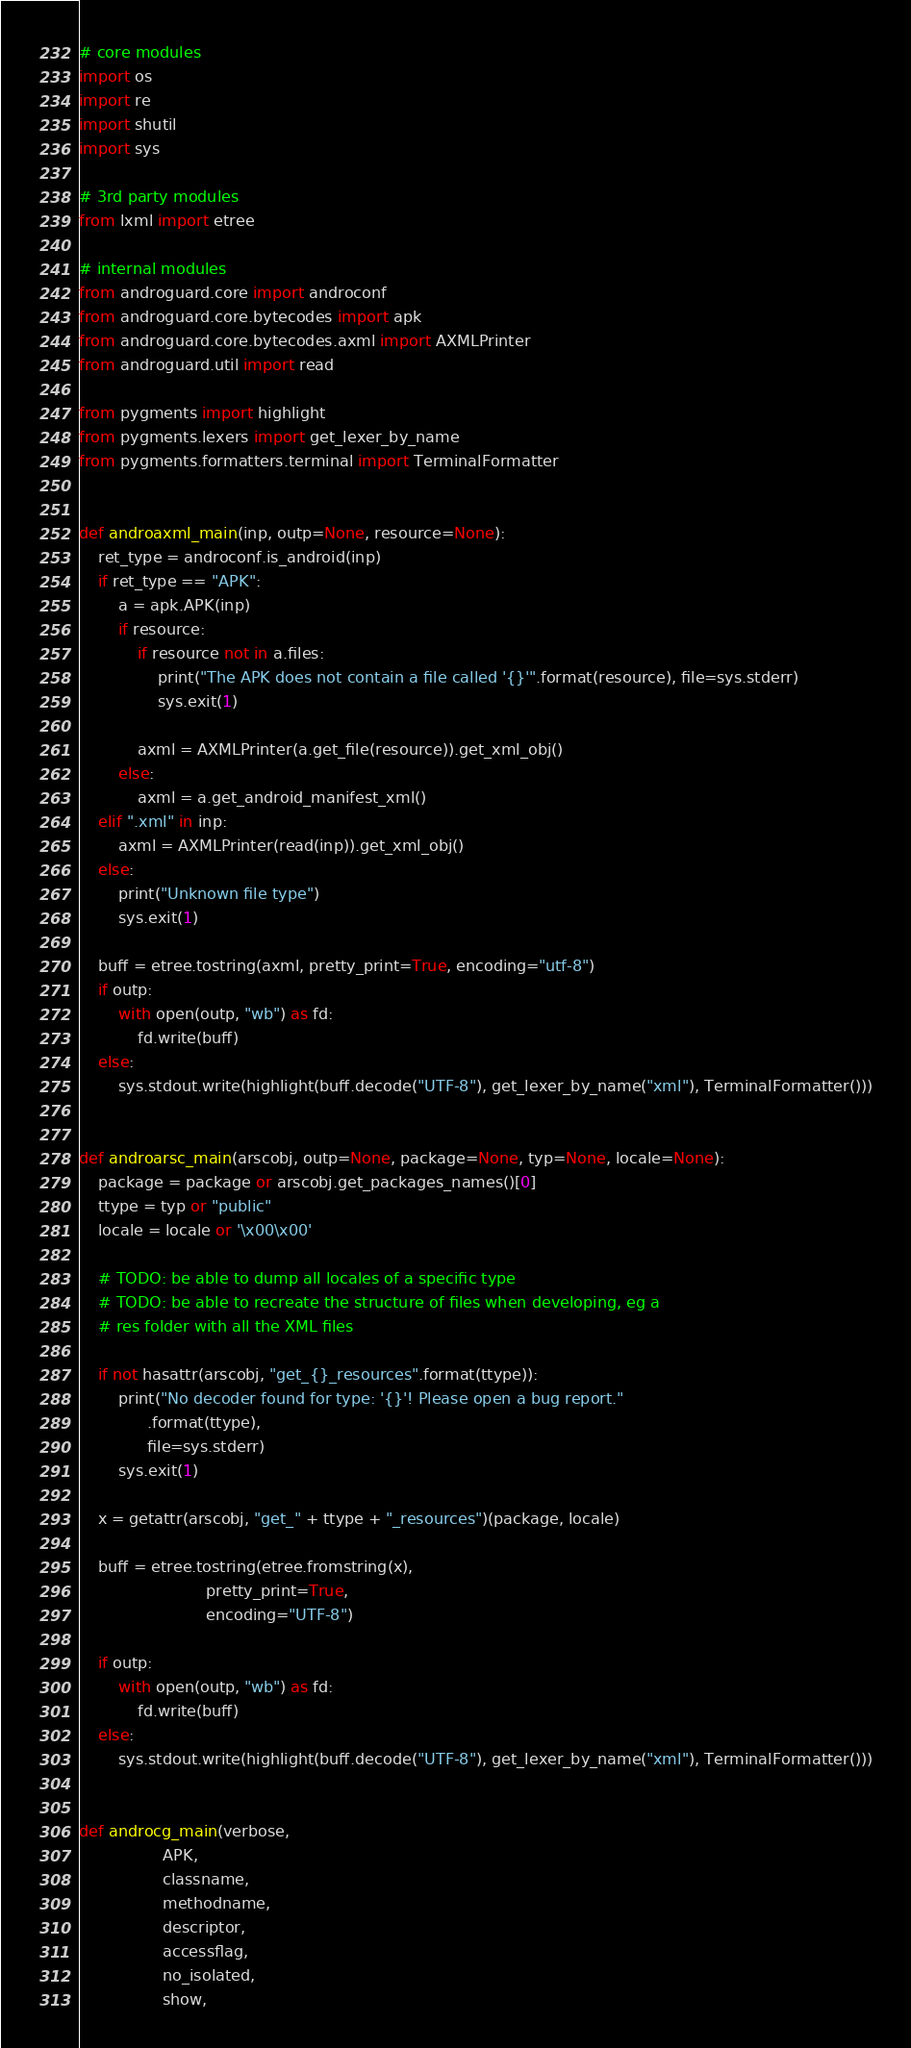Convert code to text. <code><loc_0><loc_0><loc_500><loc_500><_Python_># core modules
import os
import re
import shutil
import sys

# 3rd party modules
from lxml import etree

# internal modules
from androguard.core import androconf
from androguard.core.bytecodes import apk
from androguard.core.bytecodes.axml import AXMLPrinter
from androguard.util import read

from pygments import highlight
from pygments.lexers import get_lexer_by_name
from pygments.formatters.terminal import TerminalFormatter


def androaxml_main(inp, outp=None, resource=None):
    ret_type = androconf.is_android(inp)
    if ret_type == "APK":
        a = apk.APK(inp)
        if resource:
            if resource not in a.files:
                print("The APK does not contain a file called '{}'".format(resource), file=sys.stderr)
                sys.exit(1)

            axml = AXMLPrinter(a.get_file(resource)).get_xml_obj()
        else:
            axml = a.get_android_manifest_xml()
    elif ".xml" in inp:
        axml = AXMLPrinter(read(inp)).get_xml_obj()
    else:
        print("Unknown file type")
        sys.exit(1)

    buff = etree.tostring(axml, pretty_print=True, encoding="utf-8")
    if outp:
        with open(outp, "wb") as fd:
            fd.write(buff)
    else:
        sys.stdout.write(highlight(buff.decode("UTF-8"), get_lexer_by_name("xml"), TerminalFormatter()))


def androarsc_main(arscobj, outp=None, package=None, typ=None, locale=None):
    package = package or arscobj.get_packages_names()[0]
    ttype = typ or "public"
    locale = locale or '\x00\x00'

    # TODO: be able to dump all locales of a specific type
    # TODO: be able to recreate the structure of files when developing, eg a
    # res folder with all the XML files

    if not hasattr(arscobj, "get_{}_resources".format(ttype)):
        print("No decoder found for type: '{}'! Please open a bug report."
              .format(ttype),
              file=sys.stderr)
        sys.exit(1)

    x = getattr(arscobj, "get_" + ttype + "_resources")(package, locale)

    buff = etree.tostring(etree.fromstring(x),
                          pretty_print=True,
                          encoding="UTF-8")

    if outp:
        with open(outp, "wb") as fd:
            fd.write(buff)
    else:
        sys.stdout.write(highlight(buff.decode("UTF-8"), get_lexer_by_name("xml"), TerminalFormatter()))


def androcg_main(verbose,
                 APK,
                 classname,
                 methodname,
                 descriptor,
                 accessflag,
                 no_isolated,
                 show,</code> 